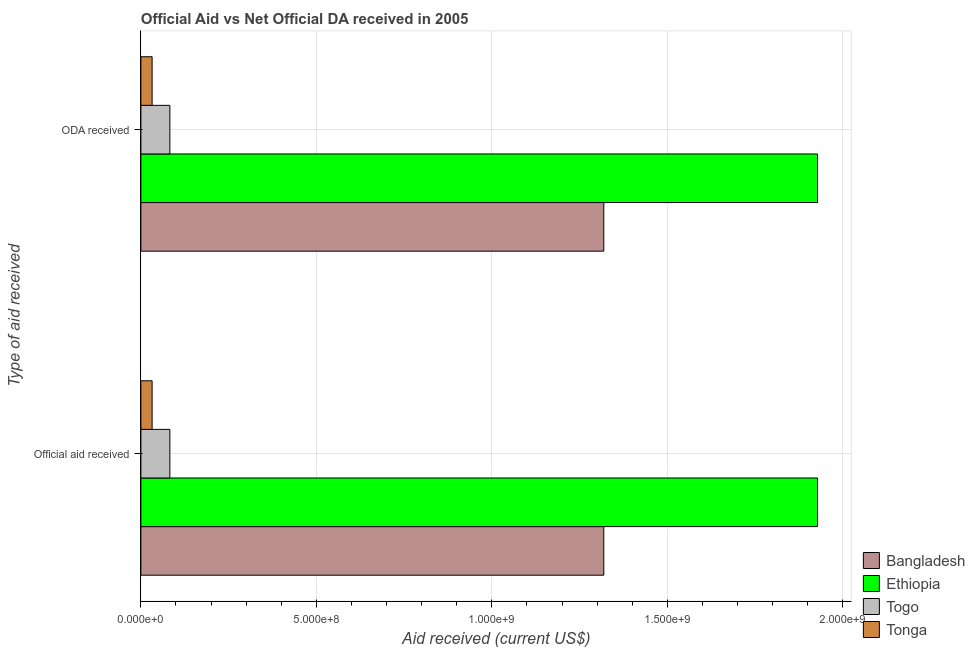How many groups of bars are there?
Give a very brief answer. 2. Are the number of bars on each tick of the Y-axis equal?
Make the answer very short. Yes. What is the label of the 1st group of bars from the top?
Provide a succinct answer. ODA received. What is the official aid received in Tonga?
Ensure brevity in your answer.  3.20e+07. Across all countries, what is the maximum oda received?
Offer a very short reply. 1.93e+09. Across all countries, what is the minimum oda received?
Make the answer very short. 3.20e+07. In which country was the oda received maximum?
Keep it short and to the point. Ethiopia. In which country was the official aid received minimum?
Make the answer very short. Tonga. What is the total official aid received in the graph?
Provide a short and direct response. 3.36e+09. What is the difference between the oda received in Tonga and that in Ethiopia?
Provide a short and direct response. -1.90e+09. What is the difference between the official aid received in Bangladesh and the oda received in Togo?
Offer a very short reply. 1.24e+09. What is the average oda received per country?
Make the answer very short. 8.40e+08. What is the ratio of the oda received in Bangladesh to that in Tonga?
Ensure brevity in your answer.  41.24. Is the oda received in Tonga less than that in Ethiopia?
Your response must be concise. Yes. In how many countries, is the official aid received greater than the average official aid received taken over all countries?
Keep it short and to the point. 2. What does the 1st bar from the top in ODA received represents?
Provide a short and direct response. Tonga. What does the 3rd bar from the bottom in Official aid received represents?
Your answer should be very brief. Togo. What is the difference between two consecutive major ticks on the X-axis?
Your answer should be compact. 5.00e+08. Does the graph contain grids?
Keep it short and to the point. Yes. How many legend labels are there?
Ensure brevity in your answer.  4. What is the title of the graph?
Your answer should be very brief. Official Aid vs Net Official DA received in 2005 . What is the label or title of the X-axis?
Ensure brevity in your answer.  Aid received (current US$). What is the label or title of the Y-axis?
Provide a succinct answer. Type of aid received. What is the Aid received (current US$) in Bangladesh in Official aid received?
Your answer should be compact. 1.32e+09. What is the Aid received (current US$) in Ethiopia in Official aid received?
Give a very brief answer. 1.93e+09. What is the Aid received (current US$) in Togo in Official aid received?
Keep it short and to the point. 8.25e+07. What is the Aid received (current US$) in Tonga in Official aid received?
Give a very brief answer. 3.20e+07. What is the Aid received (current US$) in Bangladesh in ODA received?
Give a very brief answer. 1.32e+09. What is the Aid received (current US$) of Ethiopia in ODA received?
Offer a terse response. 1.93e+09. What is the Aid received (current US$) of Togo in ODA received?
Give a very brief answer. 8.25e+07. What is the Aid received (current US$) in Tonga in ODA received?
Provide a succinct answer. 3.20e+07. Across all Type of aid received, what is the maximum Aid received (current US$) in Bangladesh?
Your answer should be compact. 1.32e+09. Across all Type of aid received, what is the maximum Aid received (current US$) of Ethiopia?
Make the answer very short. 1.93e+09. Across all Type of aid received, what is the maximum Aid received (current US$) in Togo?
Keep it short and to the point. 8.25e+07. Across all Type of aid received, what is the maximum Aid received (current US$) of Tonga?
Ensure brevity in your answer.  3.20e+07. Across all Type of aid received, what is the minimum Aid received (current US$) in Bangladesh?
Your answer should be very brief. 1.32e+09. Across all Type of aid received, what is the minimum Aid received (current US$) in Ethiopia?
Ensure brevity in your answer.  1.93e+09. Across all Type of aid received, what is the minimum Aid received (current US$) in Togo?
Keep it short and to the point. 8.25e+07. Across all Type of aid received, what is the minimum Aid received (current US$) of Tonga?
Ensure brevity in your answer.  3.20e+07. What is the total Aid received (current US$) in Bangladesh in the graph?
Make the answer very short. 2.64e+09. What is the total Aid received (current US$) of Ethiopia in the graph?
Offer a very short reply. 3.86e+09. What is the total Aid received (current US$) in Togo in the graph?
Provide a succinct answer. 1.65e+08. What is the total Aid received (current US$) of Tonga in the graph?
Give a very brief answer. 6.40e+07. What is the difference between the Aid received (current US$) of Bangladesh in Official aid received and that in ODA received?
Provide a short and direct response. 0. What is the difference between the Aid received (current US$) in Ethiopia in Official aid received and that in ODA received?
Your response must be concise. 0. What is the difference between the Aid received (current US$) of Togo in Official aid received and that in ODA received?
Offer a very short reply. 0. What is the difference between the Aid received (current US$) in Bangladesh in Official aid received and the Aid received (current US$) in Ethiopia in ODA received?
Offer a very short reply. -6.09e+08. What is the difference between the Aid received (current US$) in Bangladesh in Official aid received and the Aid received (current US$) in Togo in ODA received?
Your answer should be compact. 1.24e+09. What is the difference between the Aid received (current US$) of Bangladesh in Official aid received and the Aid received (current US$) of Tonga in ODA received?
Your answer should be compact. 1.29e+09. What is the difference between the Aid received (current US$) in Ethiopia in Official aid received and the Aid received (current US$) in Togo in ODA received?
Give a very brief answer. 1.85e+09. What is the difference between the Aid received (current US$) in Ethiopia in Official aid received and the Aid received (current US$) in Tonga in ODA received?
Give a very brief answer. 1.90e+09. What is the difference between the Aid received (current US$) of Togo in Official aid received and the Aid received (current US$) of Tonga in ODA received?
Keep it short and to the point. 5.06e+07. What is the average Aid received (current US$) of Bangladesh per Type of aid received?
Your response must be concise. 1.32e+09. What is the average Aid received (current US$) in Ethiopia per Type of aid received?
Provide a short and direct response. 1.93e+09. What is the average Aid received (current US$) of Togo per Type of aid received?
Offer a very short reply. 8.25e+07. What is the average Aid received (current US$) of Tonga per Type of aid received?
Ensure brevity in your answer.  3.20e+07. What is the difference between the Aid received (current US$) of Bangladesh and Aid received (current US$) of Ethiopia in Official aid received?
Ensure brevity in your answer.  -6.09e+08. What is the difference between the Aid received (current US$) in Bangladesh and Aid received (current US$) in Togo in Official aid received?
Your response must be concise. 1.24e+09. What is the difference between the Aid received (current US$) of Bangladesh and Aid received (current US$) of Tonga in Official aid received?
Give a very brief answer. 1.29e+09. What is the difference between the Aid received (current US$) of Ethiopia and Aid received (current US$) of Togo in Official aid received?
Make the answer very short. 1.85e+09. What is the difference between the Aid received (current US$) of Ethiopia and Aid received (current US$) of Tonga in Official aid received?
Ensure brevity in your answer.  1.90e+09. What is the difference between the Aid received (current US$) in Togo and Aid received (current US$) in Tonga in Official aid received?
Offer a terse response. 5.06e+07. What is the difference between the Aid received (current US$) of Bangladesh and Aid received (current US$) of Ethiopia in ODA received?
Provide a succinct answer. -6.09e+08. What is the difference between the Aid received (current US$) of Bangladesh and Aid received (current US$) of Togo in ODA received?
Your answer should be very brief. 1.24e+09. What is the difference between the Aid received (current US$) of Bangladesh and Aid received (current US$) of Tonga in ODA received?
Provide a succinct answer. 1.29e+09. What is the difference between the Aid received (current US$) in Ethiopia and Aid received (current US$) in Togo in ODA received?
Your answer should be compact. 1.85e+09. What is the difference between the Aid received (current US$) in Ethiopia and Aid received (current US$) in Tonga in ODA received?
Offer a terse response. 1.90e+09. What is the difference between the Aid received (current US$) of Togo and Aid received (current US$) of Tonga in ODA received?
Offer a very short reply. 5.06e+07. What is the ratio of the Aid received (current US$) in Bangladesh in Official aid received to that in ODA received?
Your response must be concise. 1. What is the difference between the highest and the second highest Aid received (current US$) of Bangladesh?
Provide a short and direct response. 0. What is the difference between the highest and the second highest Aid received (current US$) in Togo?
Offer a very short reply. 0. What is the difference between the highest and the lowest Aid received (current US$) in Bangladesh?
Make the answer very short. 0. What is the difference between the highest and the lowest Aid received (current US$) of Ethiopia?
Keep it short and to the point. 0. 